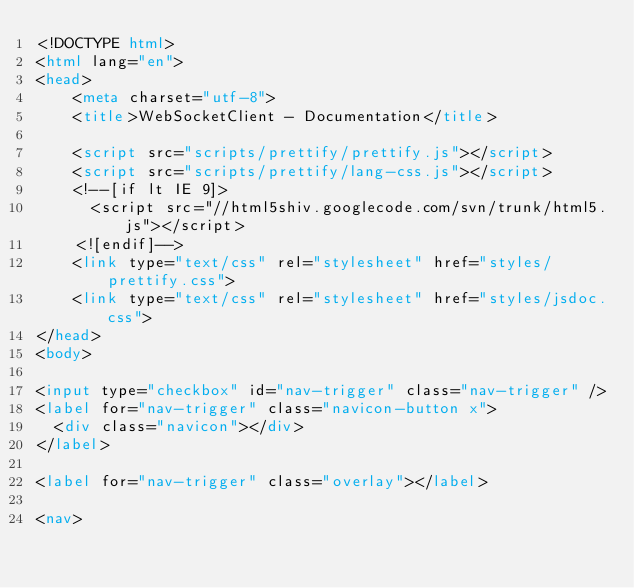Convert code to text. <code><loc_0><loc_0><loc_500><loc_500><_HTML_><!DOCTYPE html>
<html lang="en">
<head>
    <meta charset="utf-8">
    <title>WebSocketClient - Documentation</title>

    <script src="scripts/prettify/prettify.js"></script>
    <script src="scripts/prettify/lang-css.js"></script>
    <!--[if lt IE 9]>
      <script src="//html5shiv.googlecode.com/svn/trunk/html5.js"></script>
    <![endif]-->
    <link type="text/css" rel="stylesheet" href="styles/prettify.css">
    <link type="text/css" rel="stylesheet" href="styles/jsdoc.css">
</head>
<body>

<input type="checkbox" id="nav-trigger" class="nav-trigger" />
<label for="nav-trigger" class="navicon-button x">
  <div class="navicon"></div>
</label>

<label for="nav-trigger" class="overlay"></label>

<nav></code> 